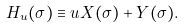<formula> <loc_0><loc_0><loc_500><loc_500>H _ { u } ( \sigma ) \equiv u X ( \sigma ) + Y ( \sigma ) .</formula> 